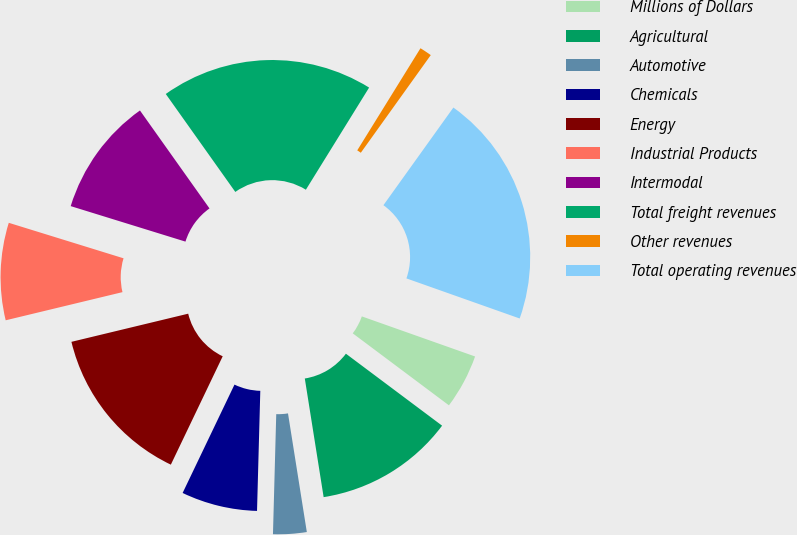<chart> <loc_0><loc_0><loc_500><loc_500><pie_chart><fcel>Millions of Dollars<fcel>Agricultural<fcel>Automotive<fcel>Chemicals<fcel>Energy<fcel>Industrial Products<fcel>Intermodal<fcel>Total freight revenues<fcel>Other revenues<fcel>Total operating revenues<nl><fcel>4.81%<fcel>12.27%<fcel>2.94%<fcel>6.67%<fcel>14.13%<fcel>8.54%<fcel>10.4%<fcel>18.65%<fcel>1.07%<fcel>20.52%<nl></chart> 